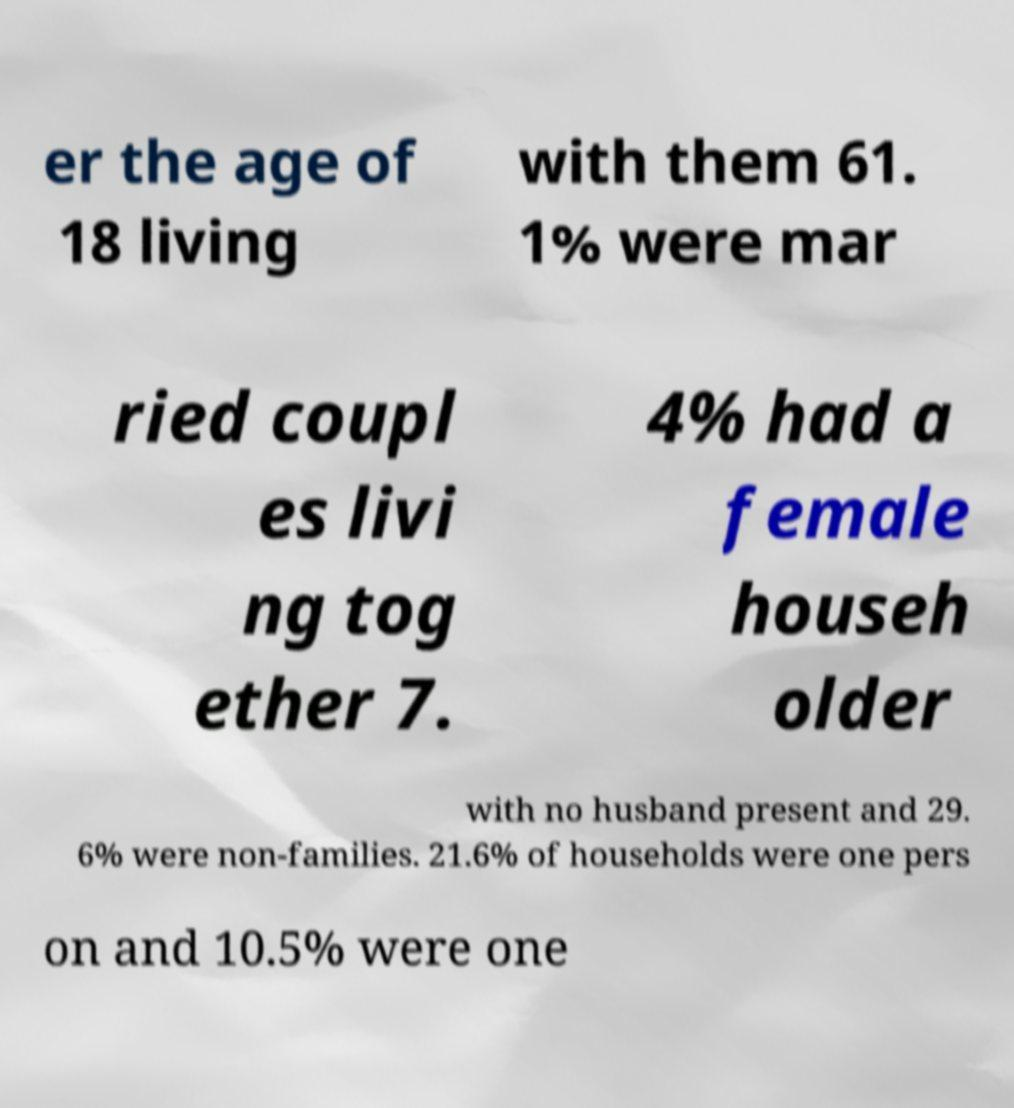Can you accurately transcribe the text from the provided image for me? er the age of 18 living with them 61. 1% were mar ried coupl es livi ng tog ether 7. 4% had a female househ older with no husband present and 29. 6% were non-families. 21.6% of households were one pers on and 10.5% were one 